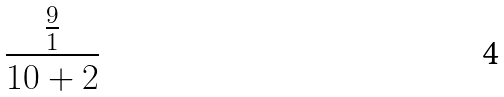Convert formula to latex. <formula><loc_0><loc_0><loc_500><loc_500>\frac { \frac { 9 } { 1 } } { 1 0 + 2 }</formula> 